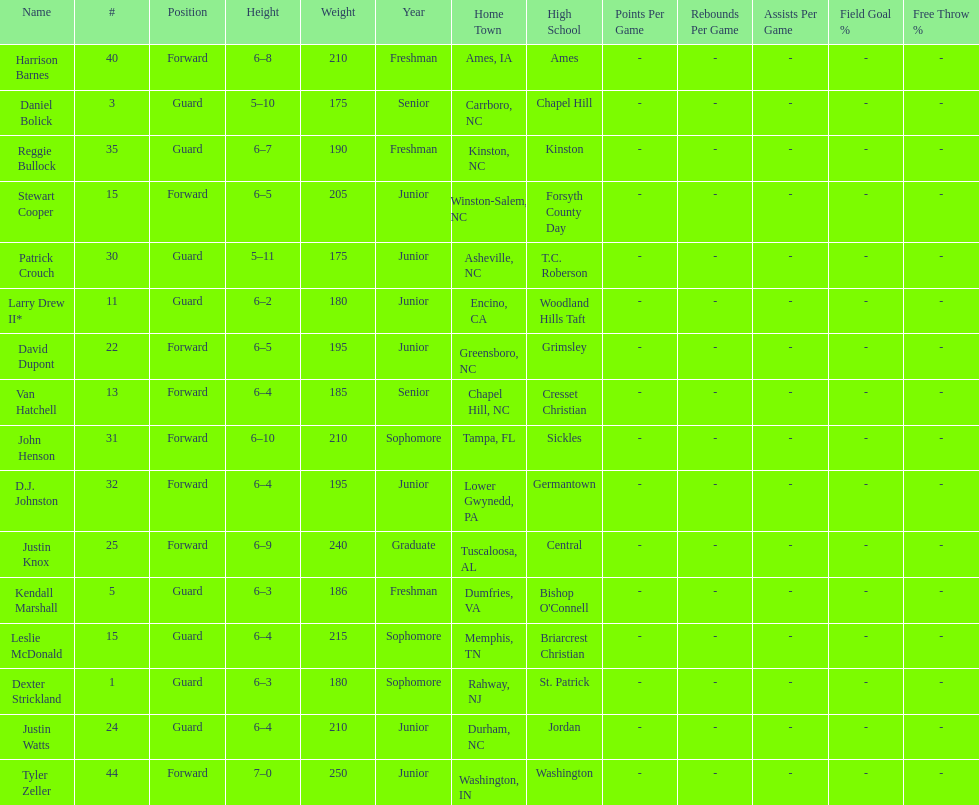What was the quantity of freshmen in the team? 3. 